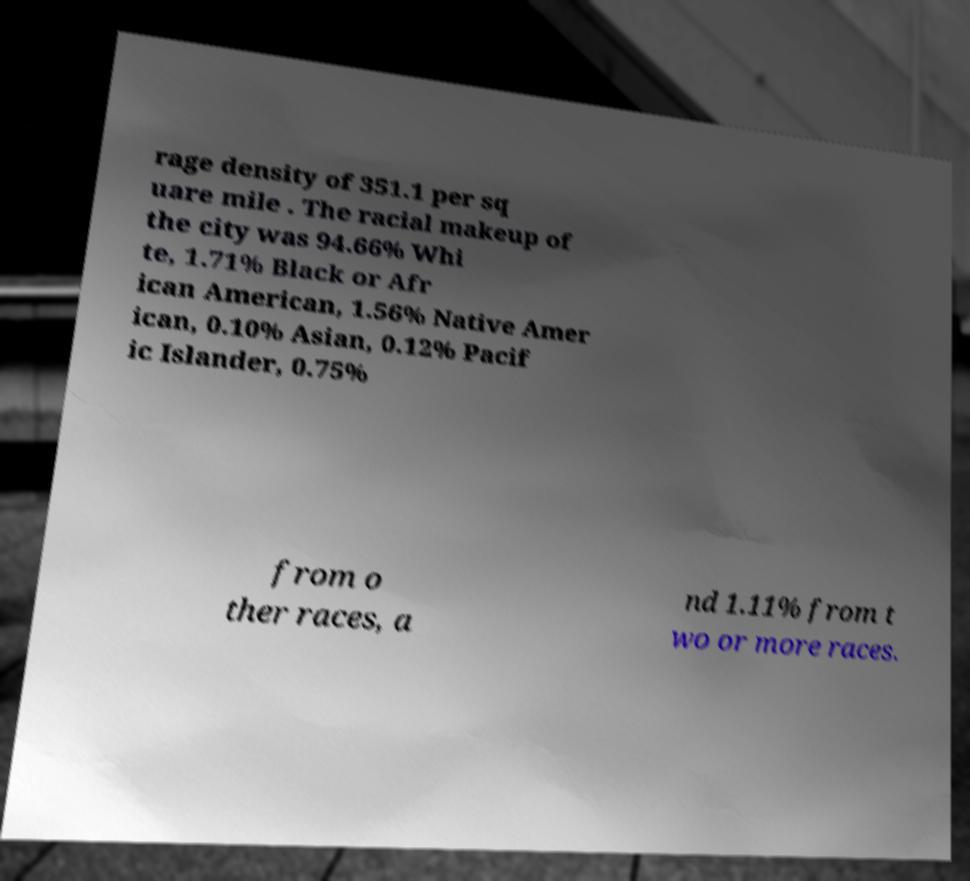Can you read and provide the text displayed in the image?This photo seems to have some interesting text. Can you extract and type it out for me? rage density of 351.1 per sq uare mile . The racial makeup of the city was 94.66% Whi te, 1.71% Black or Afr ican American, 1.56% Native Amer ican, 0.10% Asian, 0.12% Pacif ic Islander, 0.75% from o ther races, a nd 1.11% from t wo or more races. 